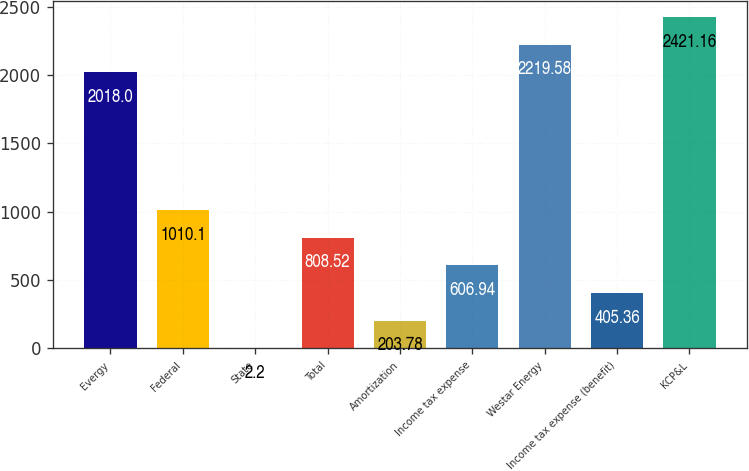Convert chart. <chart><loc_0><loc_0><loc_500><loc_500><bar_chart><fcel>Evergy<fcel>Federal<fcel>State<fcel>Total<fcel>Amortization<fcel>Income tax expense<fcel>Westar Energy<fcel>Income tax expense (benefit)<fcel>KCP&L<nl><fcel>2018<fcel>1010.1<fcel>2.2<fcel>808.52<fcel>203.78<fcel>606.94<fcel>2219.58<fcel>405.36<fcel>2421.16<nl></chart> 